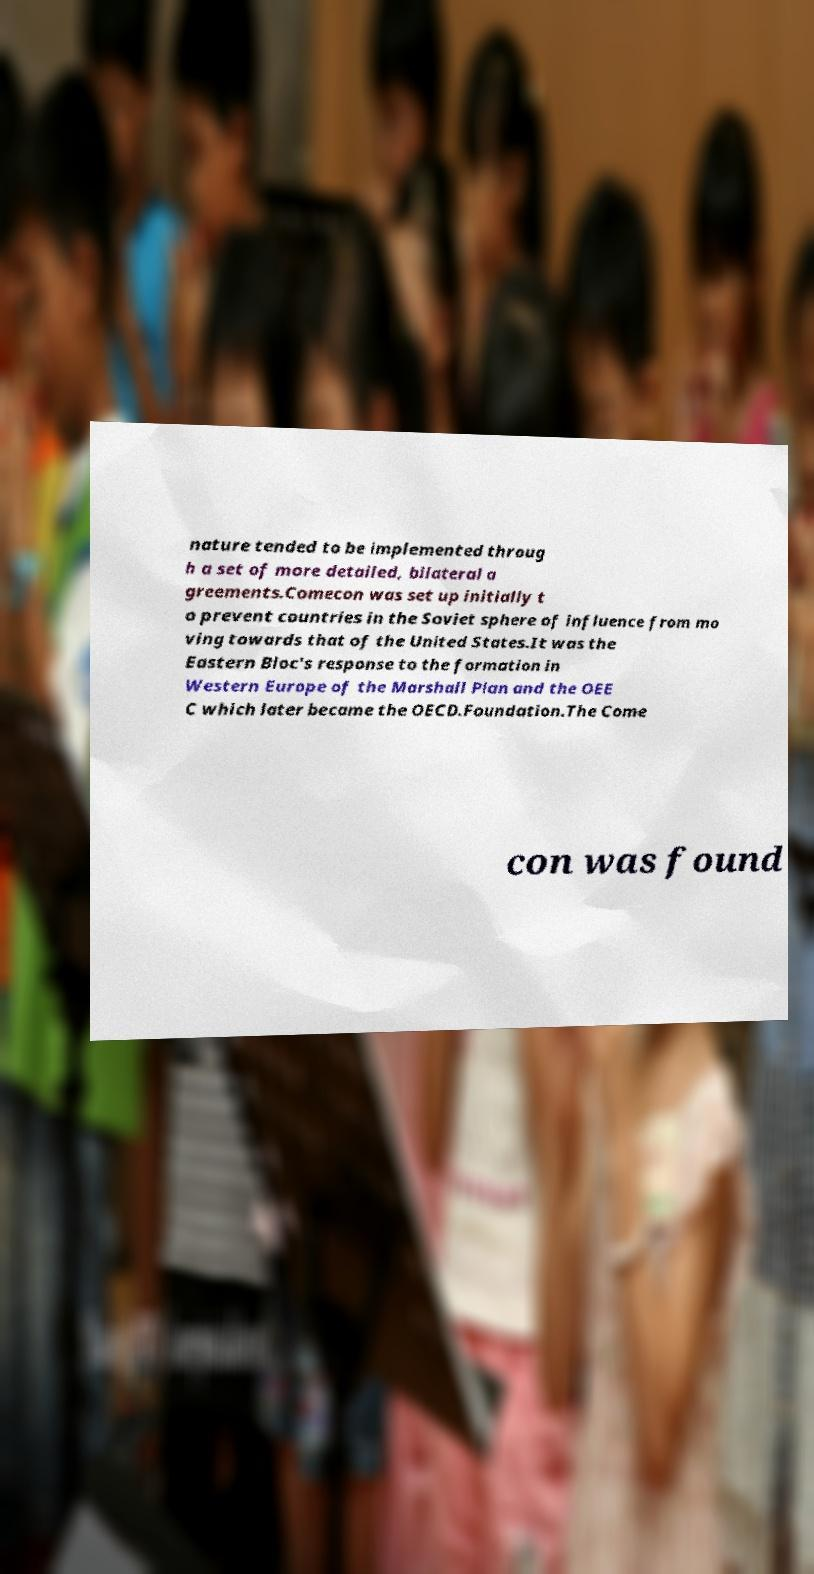Can you read and provide the text displayed in the image?This photo seems to have some interesting text. Can you extract and type it out for me? nature tended to be implemented throug h a set of more detailed, bilateral a greements.Comecon was set up initially t o prevent countries in the Soviet sphere of influence from mo ving towards that of the United States.It was the Eastern Bloc's response to the formation in Western Europe of the Marshall Plan and the OEE C which later became the OECD.Foundation.The Come con was found 